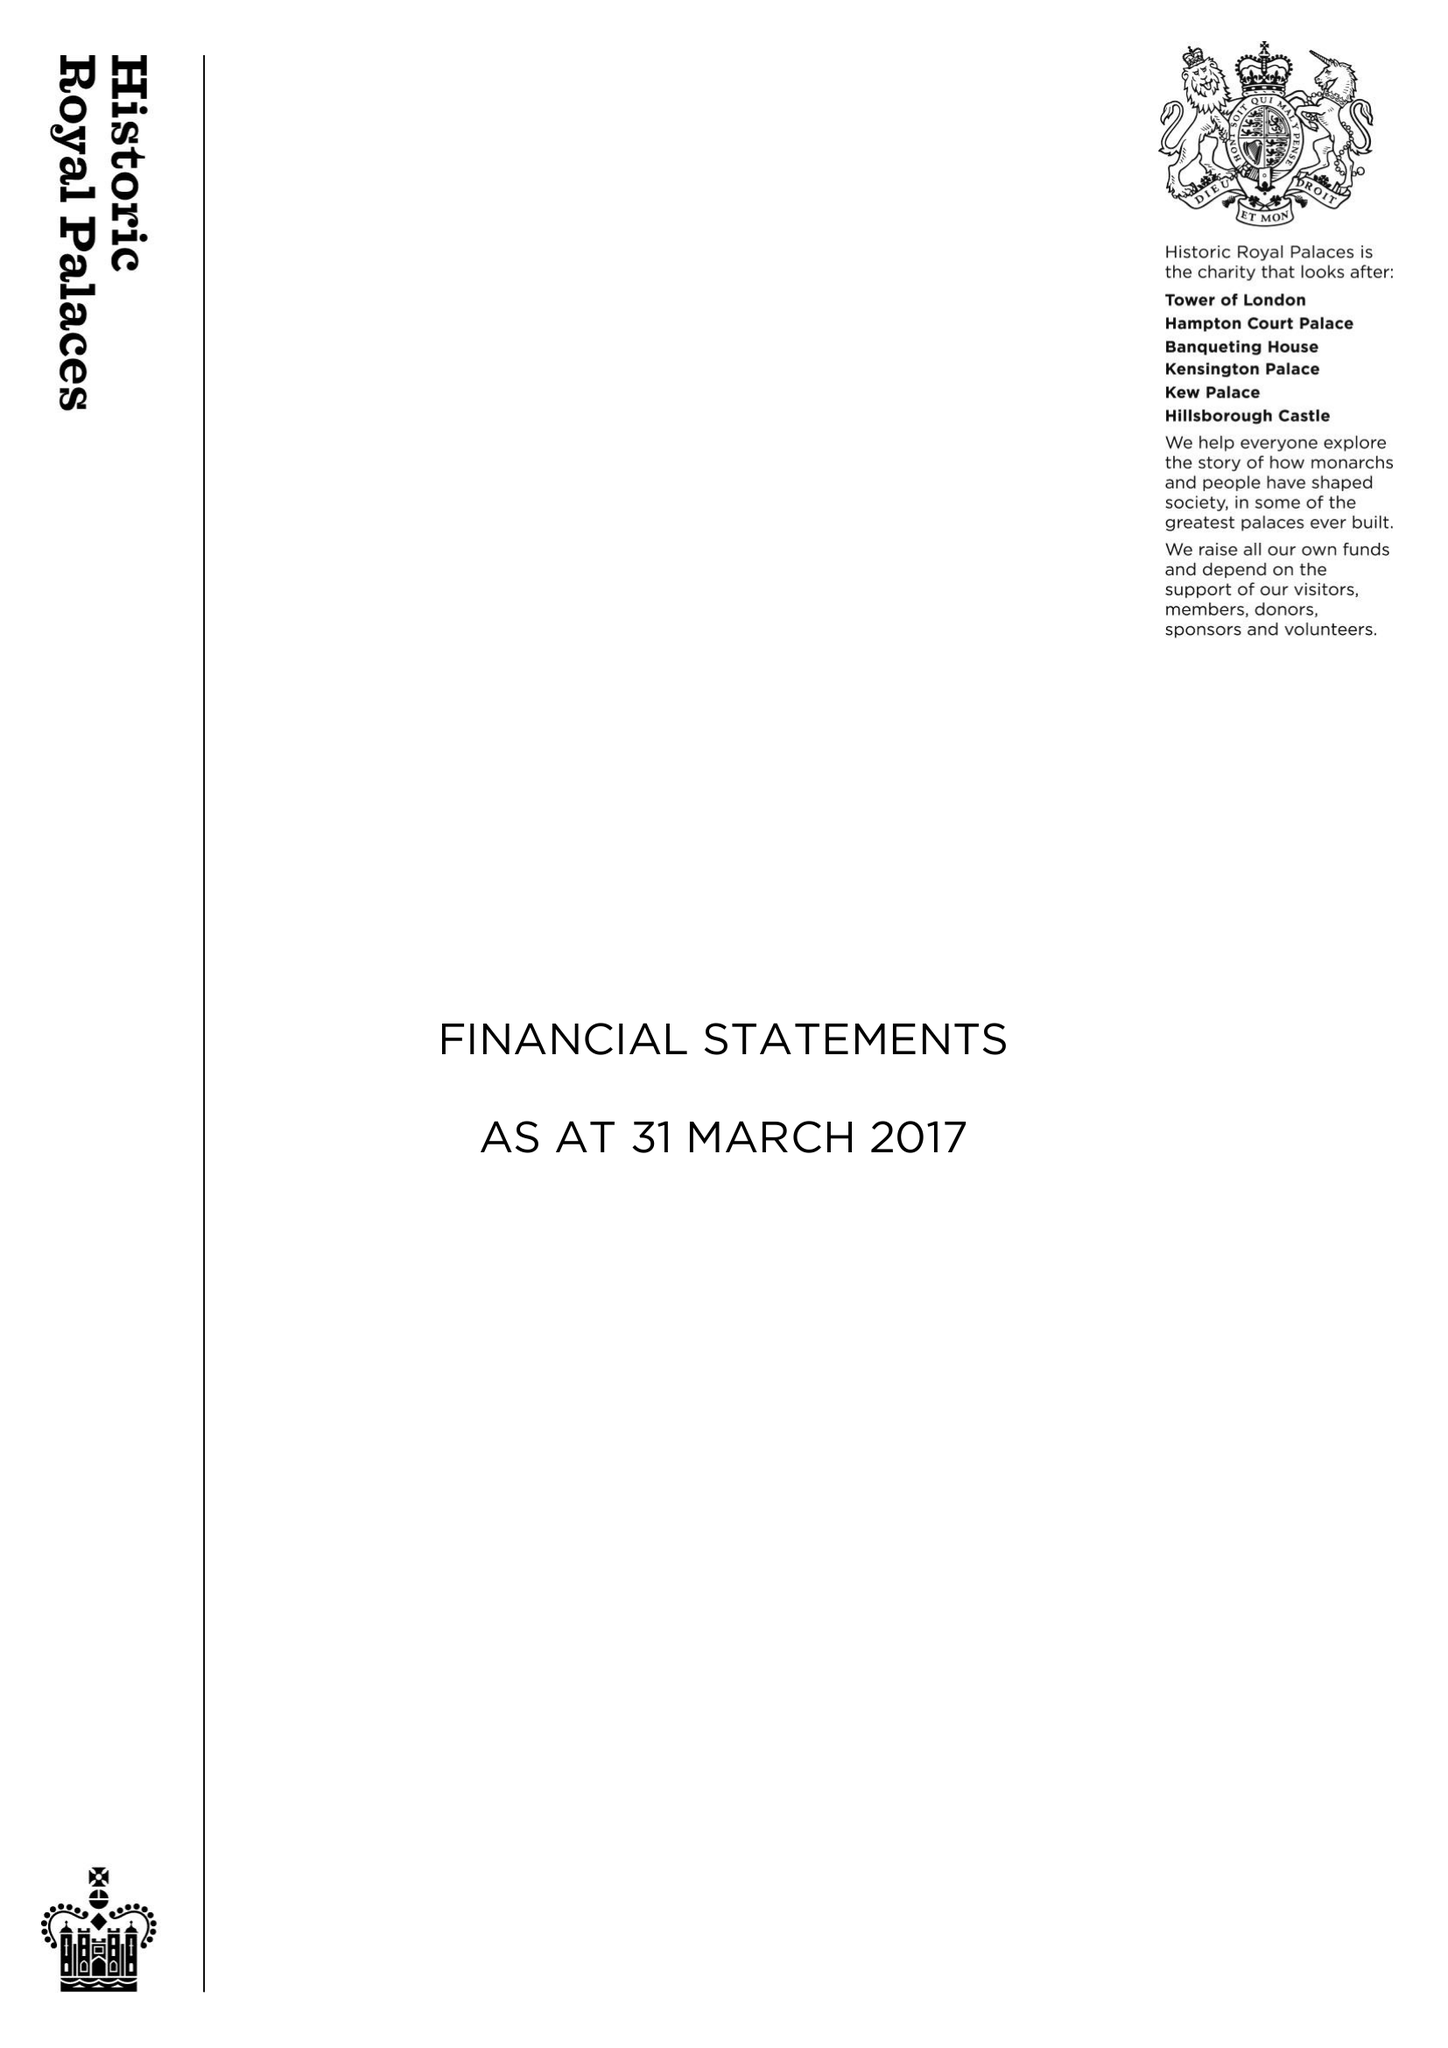What is the value for the income_annually_in_british_pounds?
Answer the question using a single word or phrase. 91497000.00 